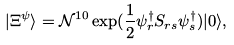Convert formula to latex. <formula><loc_0><loc_0><loc_500><loc_500>| \Xi ^ { \psi } \rangle = \mathcal { N } ^ { 1 0 } \exp ( \frac { 1 } { 2 } \psi _ { r } ^ { \dag } S _ { r s } \psi _ { s } ^ { \dag } ) | 0 \rangle ,</formula> 